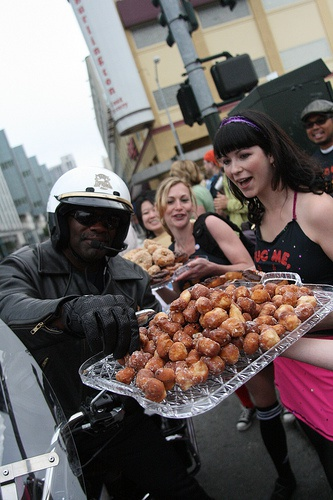Describe the objects in this image and their specific colors. I can see people in white, black, gray, and darkgray tones, people in white, black, gray, and darkgray tones, motorcycle in white, darkgray, black, lightgray, and gray tones, donut in white, brown, maroon, and black tones, and people in white, black, gray, darkgray, and lightpink tones in this image. 